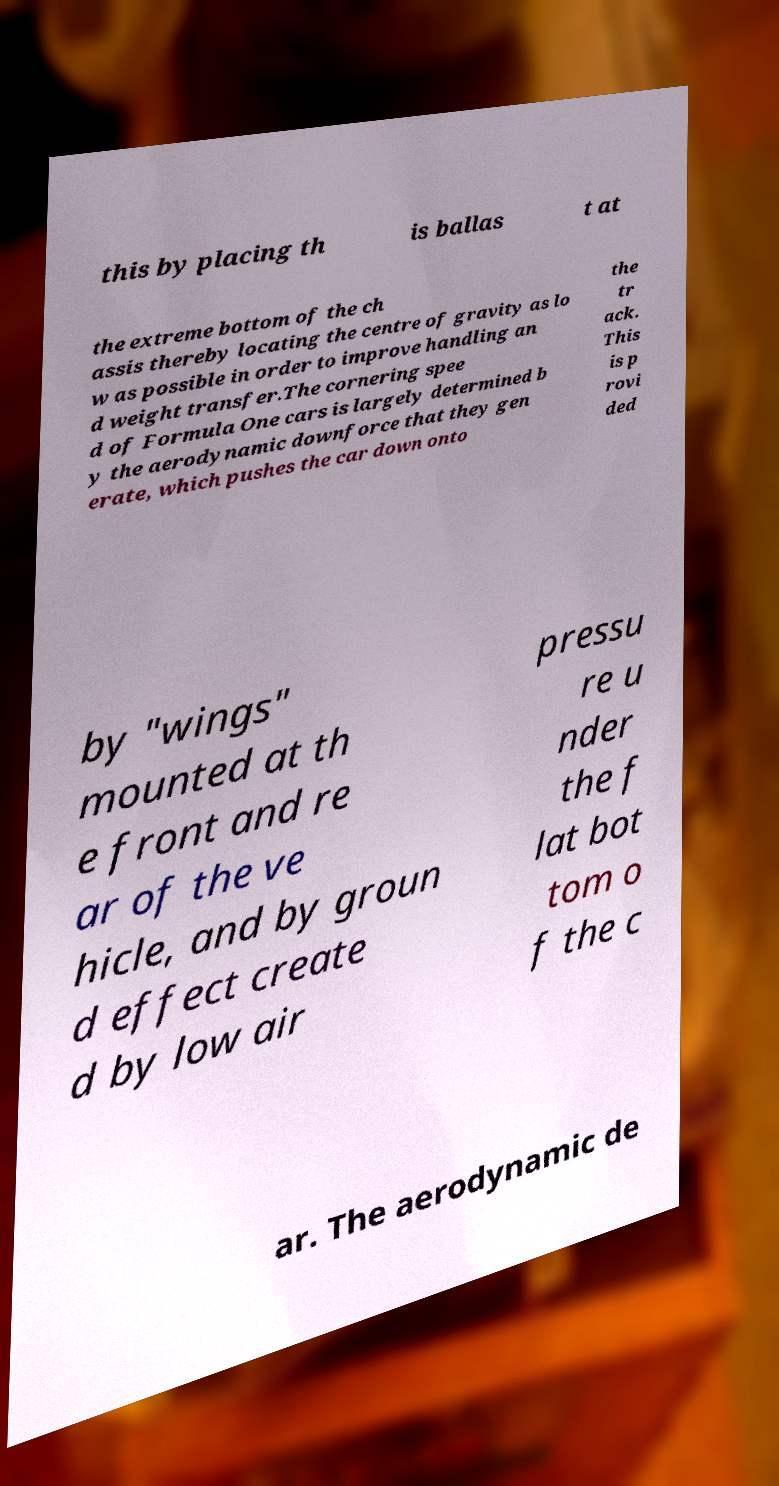I need the written content from this picture converted into text. Can you do that? this by placing th is ballas t at the extreme bottom of the ch assis thereby locating the centre of gravity as lo w as possible in order to improve handling an d weight transfer.The cornering spee d of Formula One cars is largely determined b y the aerodynamic downforce that they gen erate, which pushes the car down onto the tr ack. This is p rovi ded by "wings" mounted at th e front and re ar of the ve hicle, and by groun d effect create d by low air pressu re u nder the f lat bot tom o f the c ar. The aerodynamic de 